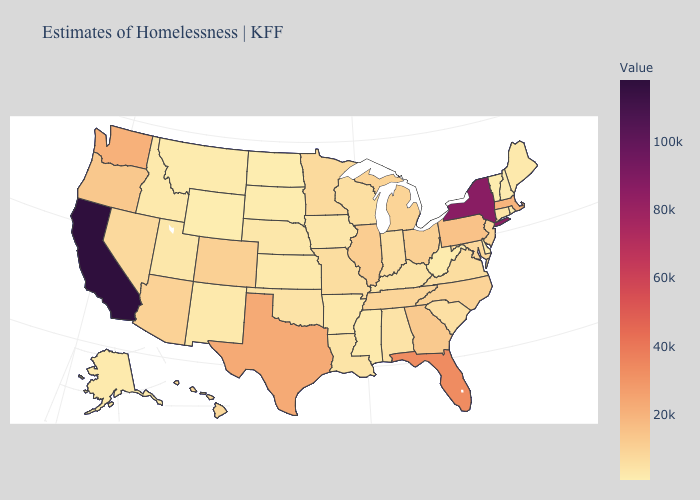Which states hav the highest value in the MidWest?
Keep it brief. Illinois. Among the states that border Maryland , which have the highest value?
Be succinct. Pennsylvania. Does Delaware have the lowest value in the South?
Be succinct. Yes. Which states have the lowest value in the South?
Give a very brief answer. Delaware. Does the map have missing data?
Write a very short answer. No. Does Ohio have the lowest value in the MidWest?
Short answer required. No. 